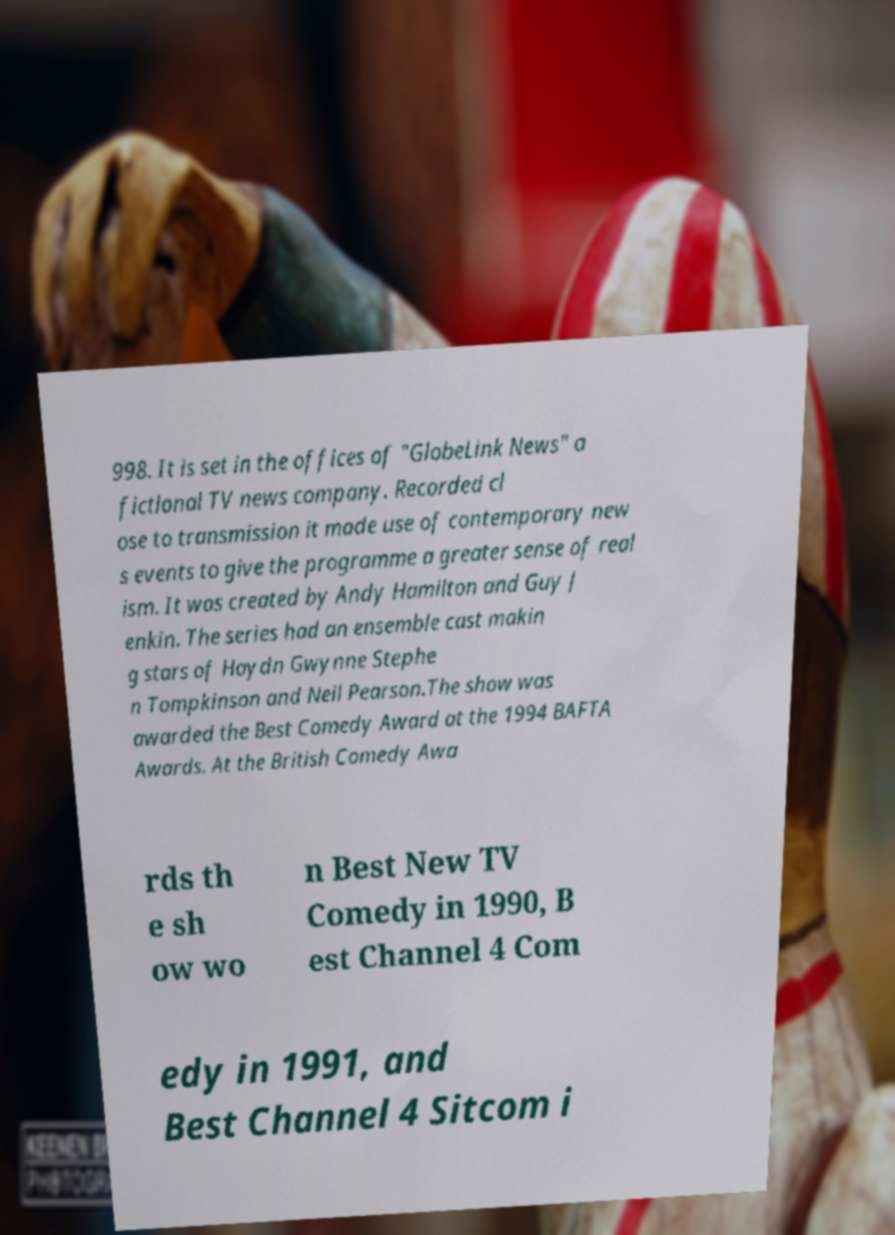What messages or text are displayed in this image? I need them in a readable, typed format. 998. It is set in the offices of "GlobeLink News" a fictional TV news company. Recorded cl ose to transmission it made use of contemporary new s events to give the programme a greater sense of real ism. It was created by Andy Hamilton and Guy J enkin. The series had an ensemble cast makin g stars of Haydn Gwynne Stephe n Tompkinson and Neil Pearson.The show was awarded the Best Comedy Award at the 1994 BAFTA Awards. At the British Comedy Awa rds th e sh ow wo n Best New TV Comedy in 1990, B est Channel 4 Com edy in 1991, and Best Channel 4 Sitcom i 